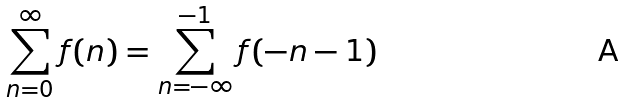Convert formula to latex. <formula><loc_0><loc_0><loc_500><loc_500>\sum _ { n = 0 } ^ { \infty } f ( n ) = \sum _ { n = - \infty } ^ { - 1 } f ( - n - 1 )</formula> 